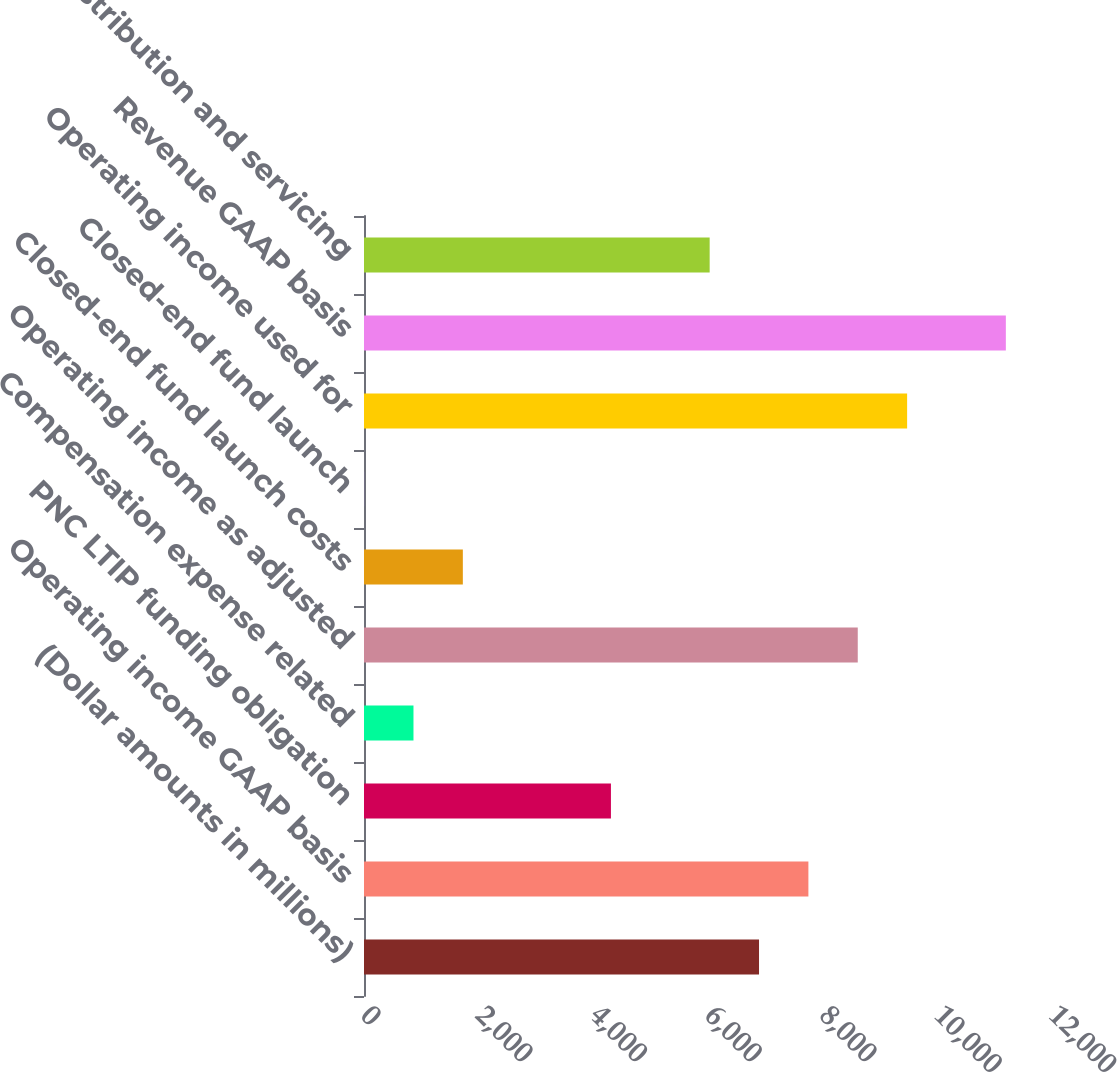<chart> <loc_0><loc_0><loc_500><loc_500><bar_chart><fcel>(Dollar amounts in millions)<fcel>Operating income GAAP basis<fcel>PNC LTIP funding obligation<fcel>Compensation expense related<fcel>Operating income as adjusted<fcel>Closed-end fund launch costs<fcel>Closed-end fund launch<fcel>Operating income used for<fcel>Revenue GAAP basis<fcel>Distribution and servicing<nl><fcel>6890<fcel>7751<fcel>4307<fcel>863<fcel>8612<fcel>1724<fcel>2<fcel>9473<fcel>11195<fcel>6029<nl></chart> 